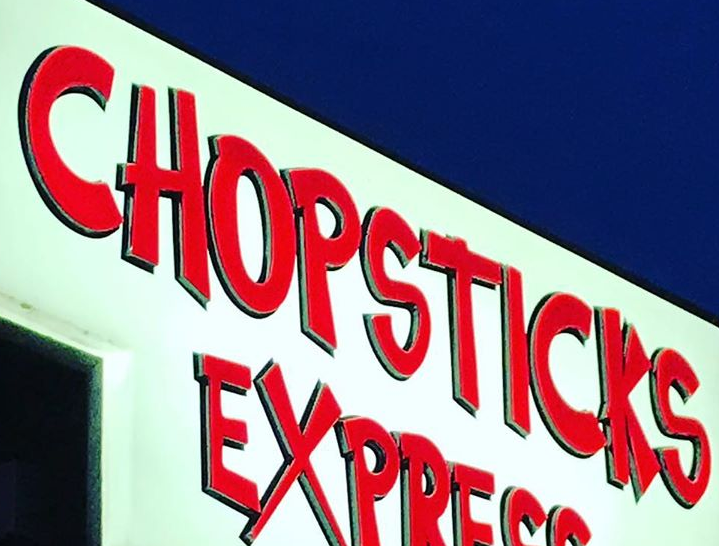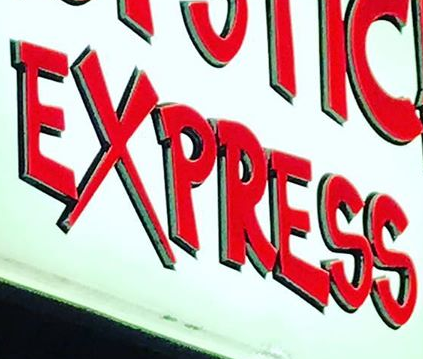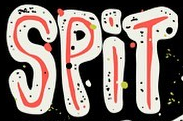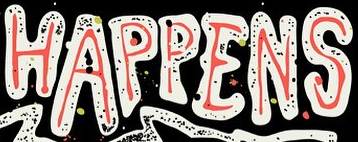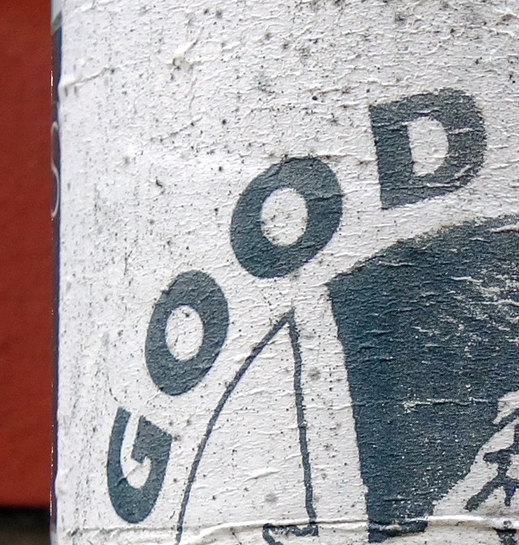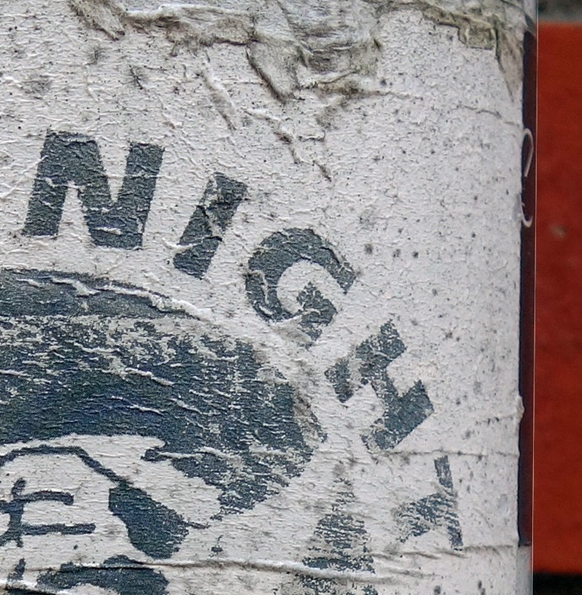What words can you see in these images in sequence, separated by a semicolon? CHOPSTICKS; EXPRESS; SPiT; HAPPENS; GOOD; NIGHT 